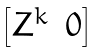Convert formula to latex. <formula><loc_0><loc_0><loc_500><loc_500>\begin{bmatrix} Z ^ { k } & 0 \end{bmatrix}</formula> 